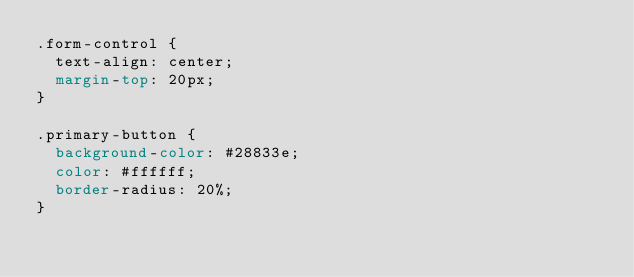Convert code to text. <code><loc_0><loc_0><loc_500><loc_500><_CSS_>.form-control {
  text-align: center;
  margin-top: 20px;
}

.primary-button {
  background-color: #28833e;
  color: #ffffff;
  border-radius: 20%;
}
</code> 